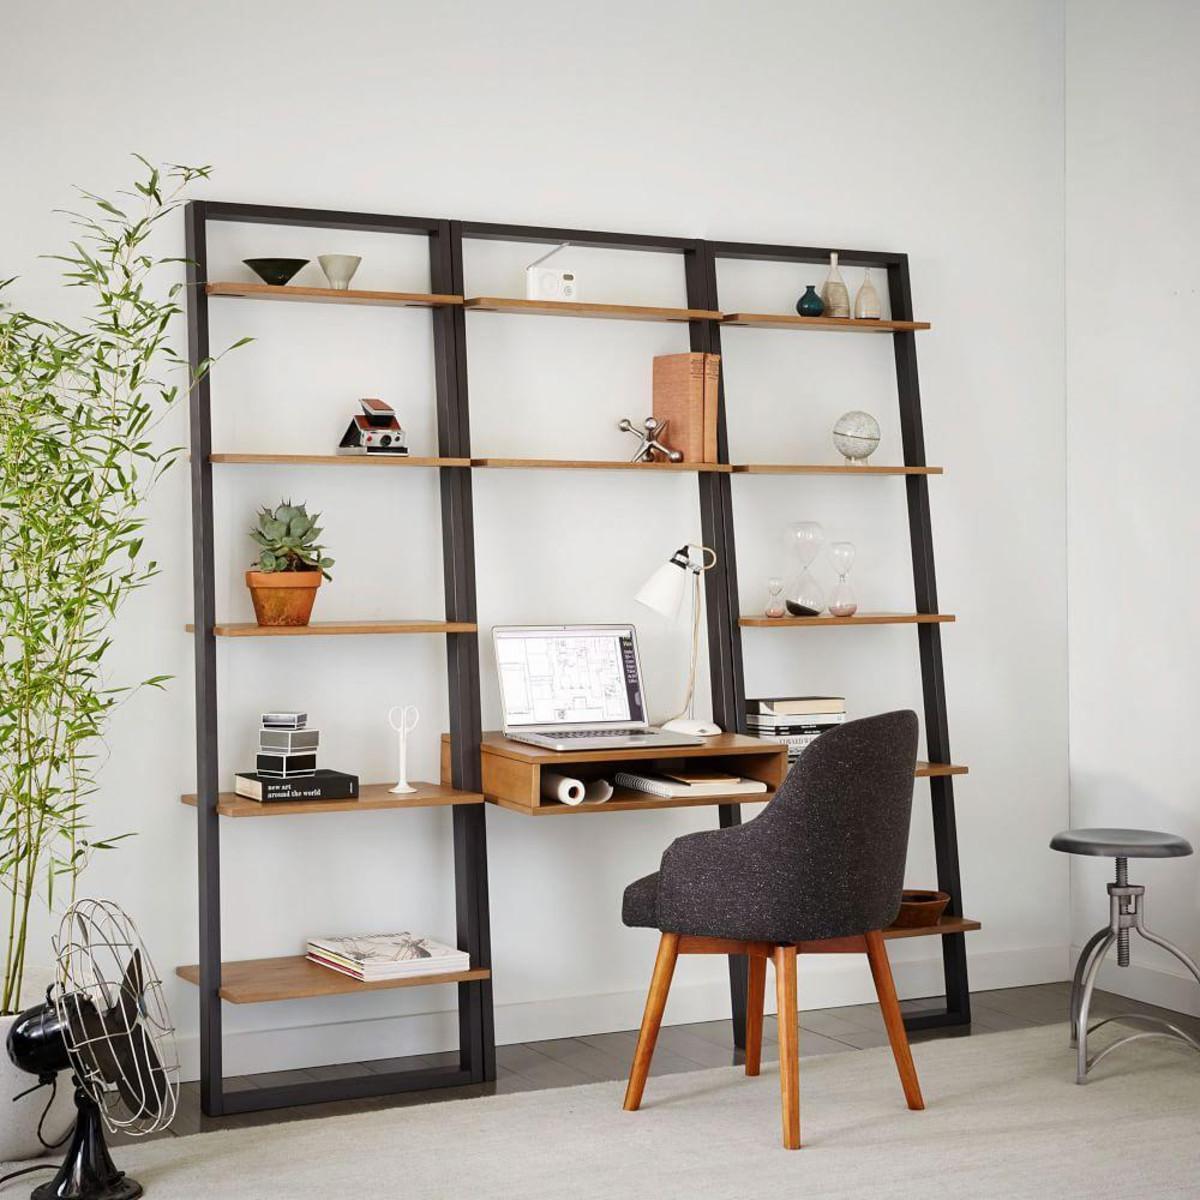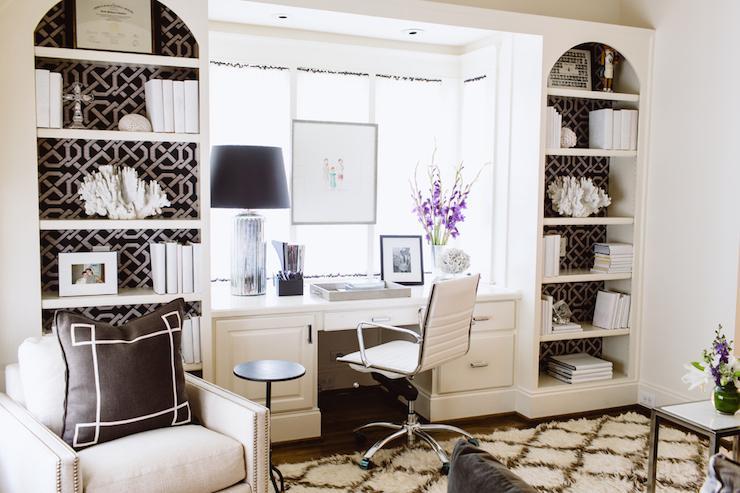The first image is the image on the left, the second image is the image on the right. For the images shown, is this caption "The left image shows a non-white shelf unit that leans against a wall like a ladder and has three vertical sections, with a small desk in the center with a chair pulled up to it." true? Answer yes or no. Yes. 